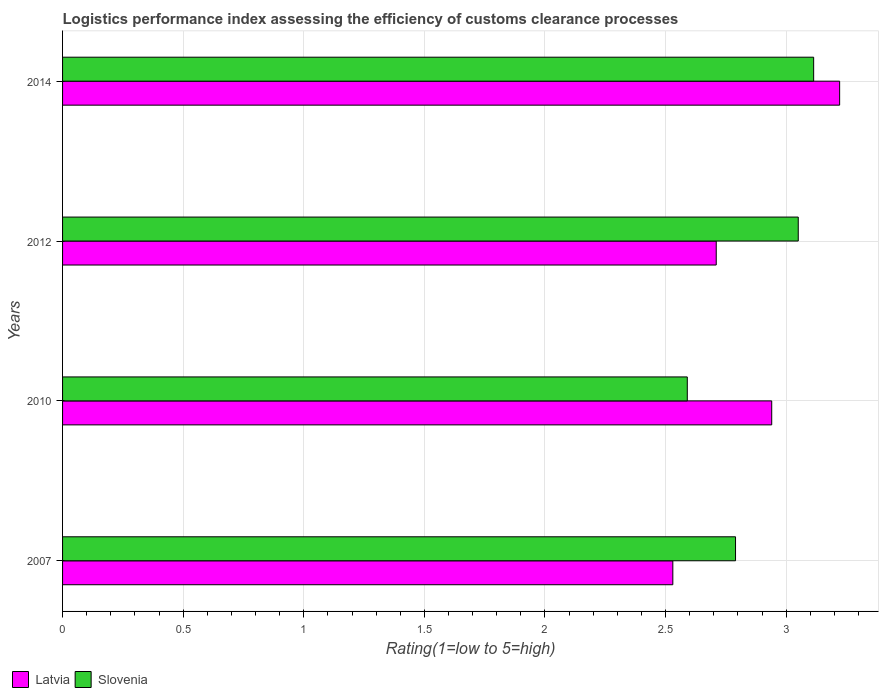How many different coloured bars are there?
Provide a short and direct response. 2. Are the number of bars per tick equal to the number of legend labels?
Offer a terse response. Yes. Are the number of bars on each tick of the Y-axis equal?
Make the answer very short. Yes. How many bars are there on the 4th tick from the bottom?
Offer a very short reply. 2. In how many cases, is the number of bars for a given year not equal to the number of legend labels?
Give a very brief answer. 0. What is the Logistic performance index in Slovenia in 2010?
Your response must be concise. 2.59. Across all years, what is the maximum Logistic performance index in Latvia?
Your response must be concise. 3.22. Across all years, what is the minimum Logistic performance index in Slovenia?
Your answer should be compact. 2.59. In which year was the Logistic performance index in Slovenia maximum?
Your response must be concise. 2014. In which year was the Logistic performance index in Slovenia minimum?
Your response must be concise. 2010. What is the total Logistic performance index in Slovenia in the graph?
Provide a short and direct response. 11.54. What is the difference between the Logistic performance index in Latvia in 2007 and that in 2010?
Give a very brief answer. -0.41. What is the difference between the Logistic performance index in Latvia in 2014 and the Logistic performance index in Slovenia in 2012?
Your response must be concise. 0.17. What is the average Logistic performance index in Slovenia per year?
Give a very brief answer. 2.89. In the year 2012, what is the difference between the Logistic performance index in Latvia and Logistic performance index in Slovenia?
Ensure brevity in your answer.  -0.34. In how many years, is the Logistic performance index in Slovenia greater than 2 ?
Ensure brevity in your answer.  4. What is the ratio of the Logistic performance index in Latvia in 2007 to that in 2010?
Ensure brevity in your answer.  0.86. Is the difference between the Logistic performance index in Latvia in 2010 and 2012 greater than the difference between the Logistic performance index in Slovenia in 2010 and 2012?
Your response must be concise. Yes. What is the difference between the highest and the second highest Logistic performance index in Latvia?
Make the answer very short. 0.28. What is the difference between the highest and the lowest Logistic performance index in Slovenia?
Ensure brevity in your answer.  0.52. What does the 2nd bar from the top in 2010 represents?
Make the answer very short. Latvia. What does the 1st bar from the bottom in 2010 represents?
Your response must be concise. Latvia. Are all the bars in the graph horizontal?
Ensure brevity in your answer.  Yes. How many years are there in the graph?
Make the answer very short. 4. Does the graph contain any zero values?
Make the answer very short. No. Where does the legend appear in the graph?
Offer a very short reply. Bottom left. How many legend labels are there?
Provide a short and direct response. 2. How are the legend labels stacked?
Your answer should be compact. Horizontal. What is the title of the graph?
Provide a short and direct response. Logistics performance index assessing the efficiency of customs clearance processes. Does "Mongolia" appear as one of the legend labels in the graph?
Provide a succinct answer. No. What is the label or title of the X-axis?
Your response must be concise. Rating(1=low to 5=high). What is the Rating(1=low to 5=high) of Latvia in 2007?
Provide a succinct answer. 2.53. What is the Rating(1=low to 5=high) in Slovenia in 2007?
Your answer should be very brief. 2.79. What is the Rating(1=low to 5=high) of Latvia in 2010?
Your answer should be very brief. 2.94. What is the Rating(1=low to 5=high) in Slovenia in 2010?
Offer a terse response. 2.59. What is the Rating(1=low to 5=high) in Latvia in 2012?
Your answer should be compact. 2.71. What is the Rating(1=low to 5=high) in Slovenia in 2012?
Your response must be concise. 3.05. What is the Rating(1=low to 5=high) of Latvia in 2014?
Offer a very short reply. 3.22. What is the Rating(1=low to 5=high) in Slovenia in 2014?
Make the answer very short. 3.11. Across all years, what is the maximum Rating(1=low to 5=high) of Latvia?
Provide a succinct answer. 3.22. Across all years, what is the maximum Rating(1=low to 5=high) of Slovenia?
Your answer should be very brief. 3.11. Across all years, what is the minimum Rating(1=low to 5=high) of Latvia?
Offer a very short reply. 2.53. Across all years, what is the minimum Rating(1=low to 5=high) in Slovenia?
Keep it short and to the point. 2.59. What is the total Rating(1=low to 5=high) in Latvia in the graph?
Keep it short and to the point. 11.4. What is the total Rating(1=low to 5=high) of Slovenia in the graph?
Provide a short and direct response. 11.54. What is the difference between the Rating(1=low to 5=high) in Latvia in 2007 and that in 2010?
Offer a terse response. -0.41. What is the difference between the Rating(1=low to 5=high) in Slovenia in 2007 and that in 2010?
Offer a terse response. 0.2. What is the difference between the Rating(1=low to 5=high) in Latvia in 2007 and that in 2012?
Your response must be concise. -0.18. What is the difference between the Rating(1=low to 5=high) of Slovenia in 2007 and that in 2012?
Provide a succinct answer. -0.26. What is the difference between the Rating(1=low to 5=high) of Latvia in 2007 and that in 2014?
Offer a very short reply. -0.69. What is the difference between the Rating(1=low to 5=high) of Slovenia in 2007 and that in 2014?
Your answer should be compact. -0.32. What is the difference between the Rating(1=low to 5=high) in Latvia in 2010 and that in 2012?
Give a very brief answer. 0.23. What is the difference between the Rating(1=low to 5=high) in Slovenia in 2010 and that in 2012?
Make the answer very short. -0.46. What is the difference between the Rating(1=low to 5=high) in Latvia in 2010 and that in 2014?
Provide a short and direct response. -0.28. What is the difference between the Rating(1=low to 5=high) in Slovenia in 2010 and that in 2014?
Offer a very short reply. -0.52. What is the difference between the Rating(1=low to 5=high) of Latvia in 2012 and that in 2014?
Provide a short and direct response. -0.51. What is the difference between the Rating(1=low to 5=high) in Slovenia in 2012 and that in 2014?
Make the answer very short. -0.06. What is the difference between the Rating(1=low to 5=high) in Latvia in 2007 and the Rating(1=low to 5=high) in Slovenia in 2010?
Ensure brevity in your answer.  -0.06. What is the difference between the Rating(1=low to 5=high) of Latvia in 2007 and the Rating(1=low to 5=high) of Slovenia in 2012?
Make the answer very short. -0.52. What is the difference between the Rating(1=low to 5=high) in Latvia in 2007 and the Rating(1=low to 5=high) in Slovenia in 2014?
Make the answer very short. -0.58. What is the difference between the Rating(1=low to 5=high) of Latvia in 2010 and the Rating(1=low to 5=high) of Slovenia in 2012?
Make the answer very short. -0.11. What is the difference between the Rating(1=low to 5=high) in Latvia in 2010 and the Rating(1=low to 5=high) in Slovenia in 2014?
Your response must be concise. -0.17. What is the difference between the Rating(1=low to 5=high) in Latvia in 2012 and the Rating(1=low to 5=high) in Slovenia in 2014?
Provide a succinct answer. -0.4. What is the average Rating(1=low to 5=high) of Latvia per year?
Offer a terse response. 2.85. What is the average Rating(1=low to 5=high) of Slovenia per year?
Your response must be concise. 2.89. In the year 2007, what is the difference between the Rating(1=low to 5=high) of Latvia and Rating(1=low to 5=high) of Slovenia?
Provide a succinct answer. -0.26. In the year 2012, what is the difference between the Rating(1=low to 5=high) in Latvia and Rating(1=low to 5=high) in Slovenia?
Provide a succinct answer. -0.34. In the year 2014, what is the difference between the Rating(1=low to 5=high) of Latvia and Rating(1=low to 5=high) of Slovenia?
Your answer should be compact. 0.11. What is the ratio of the Rating(1=low to 5=high) in Latvia in 2007 to that in 2010?
Ensure brevity in your answer.  0.86. What is the ratio of the Rating(1=low to 5=high) in Slovenia in 2007 to that in 2010?
Your response must be concise. 1.08. What is the ratio of the Rating(1=low to 5=high) in Latvia in 2007 to that in 2012?
Offer a terse response. 0.93. What is the ratio of the Rating(1=low to 5=high) of Slovenia in 2007 to that in 2012?
Offer a terse response. 0.91. What is the ratio of the Rating(1=low to 5=high) of Latvia in 2007 to that in 2014?
Your response must be concise. 0.79. What is the ratio of the Rating(1=low to 5=high) in Slovenia in 2007 to that in 2014?
Offer a very short reply. 0.9. What is the ratio of the Rating(1=low to 5=high) of Latvia in 2010 to that in 2012?
Your response must be concise. 1.08. What is the ratio of the Rating(1=low to 5=high) of Slovenia in 2010 to that in 2012?
Ensure brevity in your answer.  0.85. What is the ratio of the Rating(1=low to 5=high) in Latvia in 2010 to that in 2014?
Your response must be concise. 0.91. What is the ratio of the Rating(1=low to 5=high) of Slovenia in 2010 to that in 2014?
Offer a very short reply. 0.83. What is the ratio of the Rating(1=low to 5=high) of Latvia in 2012 to that in 2014?
Your response must be concise. 0.84. What is the ratio of the Rating(1=low to 5=high) in Slovenia in 2012 to that in 2014?
Ensure brevity in your answer.  0.98. What is the difference between the highest and the second highest Rating(1=low to 5=high) of Latvia?
Offer a terse response. 0.28. What is the difference between the highest and the second highest Rating(1=low to 5=high) of Slovenia?
Ensure brevity in your answer.  0.06. What is the difference between the highest and the lowest Rating(1=low to 5=high) of Latvia?
Ensure brevity in your answer.  0.69. What is the difference between the highest and the lowest Rating(1=low to 5=high) of Slovenia?
Keep it short and to the point. 0.52. 